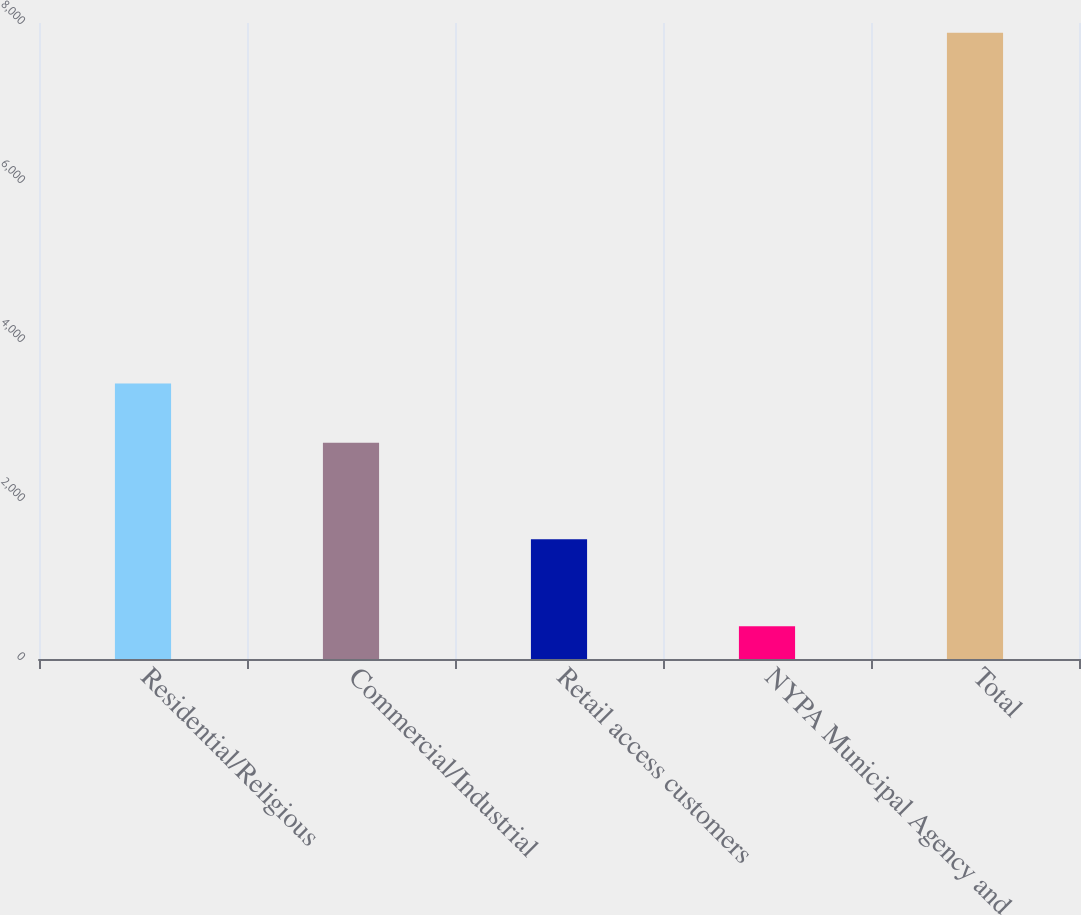Convert chart. <chart><loc_0><loc_0><loc_500><loc_500><bar_chart><fcel>Residential/Religious<fcel>Commercial/Industrial<fcel>Retail access customers<fcel>NYPA Municipal Agency and<fcel>Total<nl><fcel>3466.5<fcel>2720<fcel>1507<fcel>413<fcel>7878<nl></chart> 